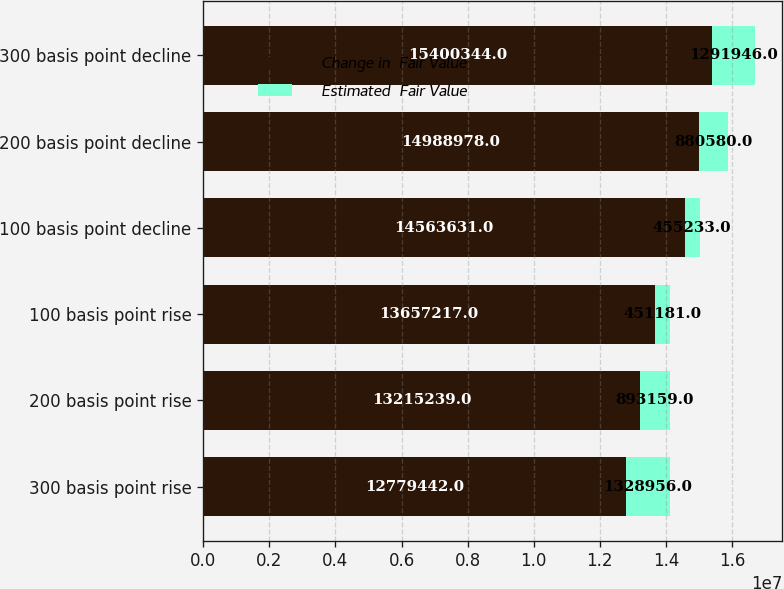<chart> <loc_0><loc_0><loc_500><loc_500><stacked_bar_chart><ecel><fcel>300 basis point rise<fcel>200 basis point rise<fcel>100 basis point rise<fcel>100 basis point decline<fcel>200 basis point decline<fcel>300 basis point decline<nl><fcel>Change in  Fair Value<fcel>1.27794e+07<fcel>1.32152e+07<fcel>1.36572e+07<fcel>1.45636e+07<fcel>1.4989e+07<fcel>1.54003e+07<nl><fcel>Estimated  Fair Value<fcel>1.32896e+06<fcel>893159<fcel>451181<fcel>455233<fcel>880580<fcel>1.29195e+06<nl></chart> 